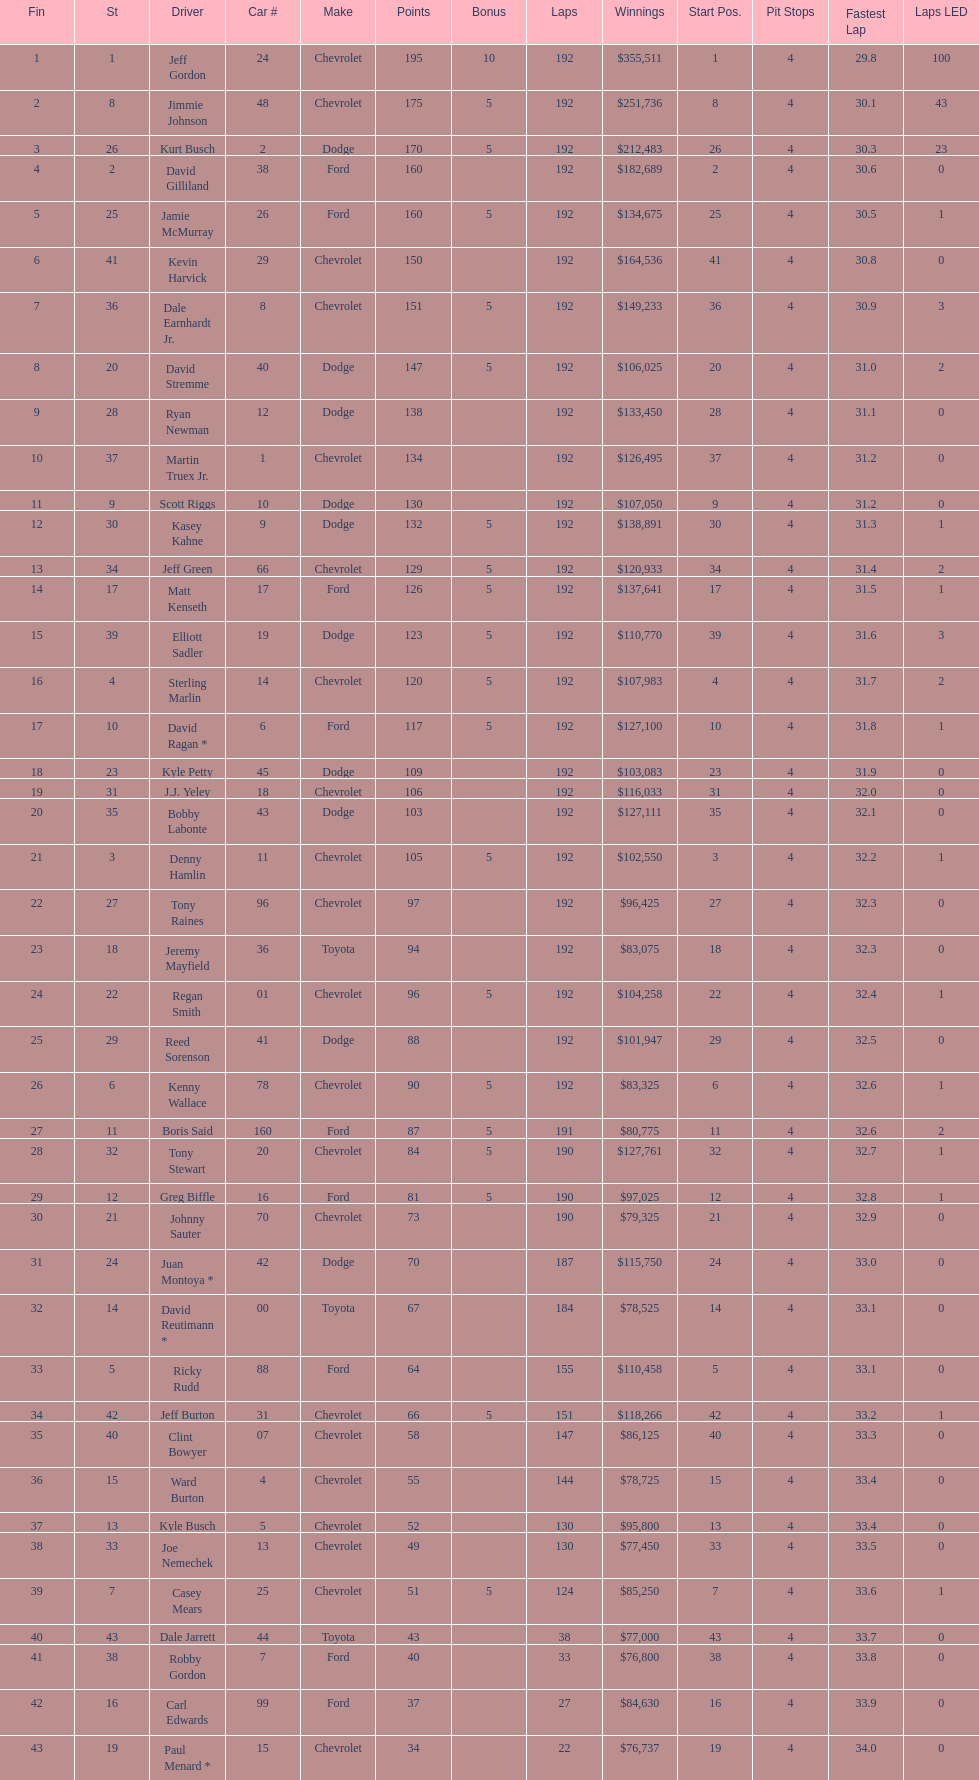How many drivers placed below tony stewart? 15. 